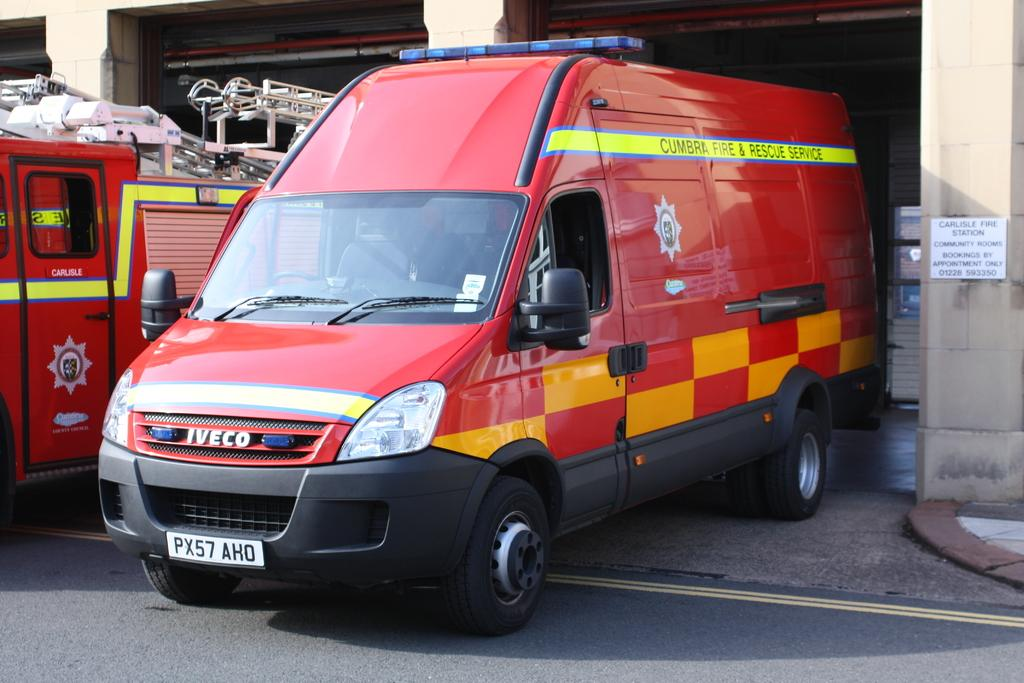<image>
Relay a brief, clear account of the picture shown. A fire and rescue service truck was made by IVECO. 